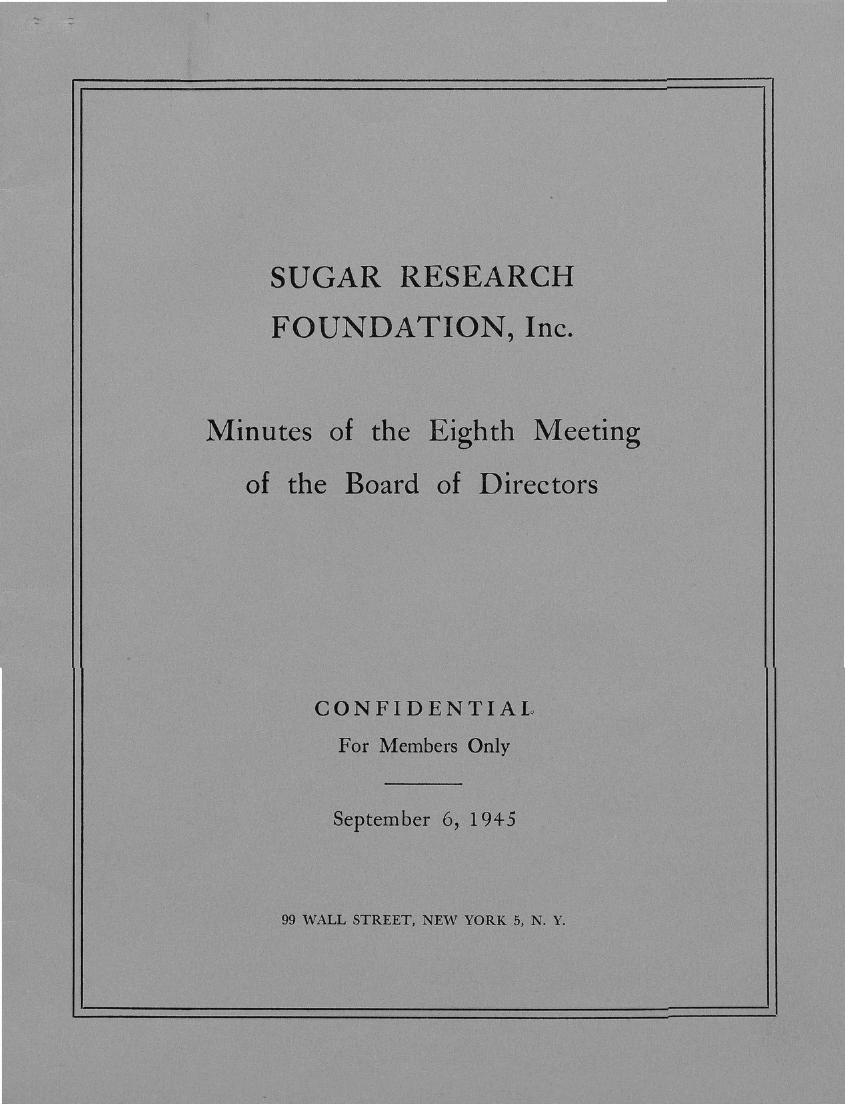Specify some key components in this picture. The minutes of the eighth meeting of the board of directors of SUGAR RESEARCH FOUNDATION, Inc. are mentioned in this passage. The document specifies that the date mentioned is September 6, 1945. 